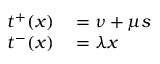Convert formula to latex. <formula><loc_0><loc_0><loc_500><loc_500>\begin{array} { r l } { t ^ { + } ( x ) } & = \nu + \mu s } \\ { t ^ { - } ( x ) } & = \lambda x } \end{array}</formula> 